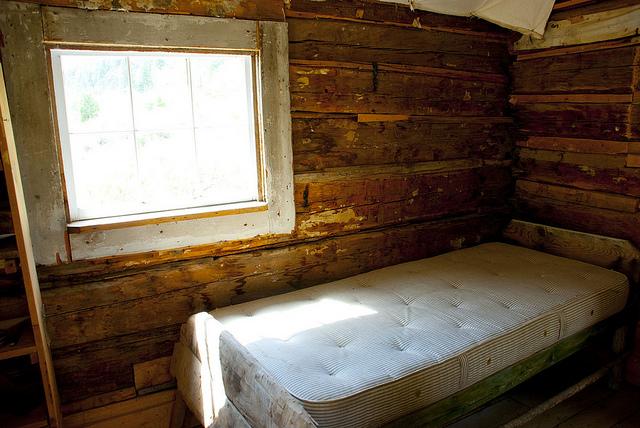What color is the room?
Answer briefly. Brown. Is the bed made of nails?
Give a very brief answer. No. What shape is the window?
Keep it brief. Square. 